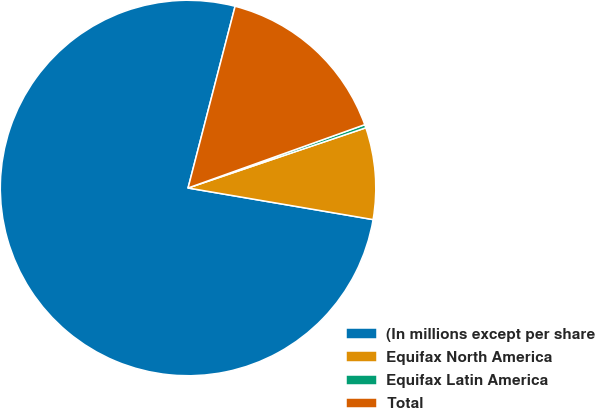Convert chart. <chart><loc_0><loc_0><loc_500><loc_500><pie_chart><fcel>(In millions except per share<fcel>Equifax North America<fcel>Equifax Latin America<fcel>Total<nl><fcel>76.34%<fcel>7.89%<fcel>0.28%<fcel>15.49%<nl></chart> 